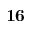<formula> <loc_0><loc_0><loc_500><loc_500>1 6</formula> 